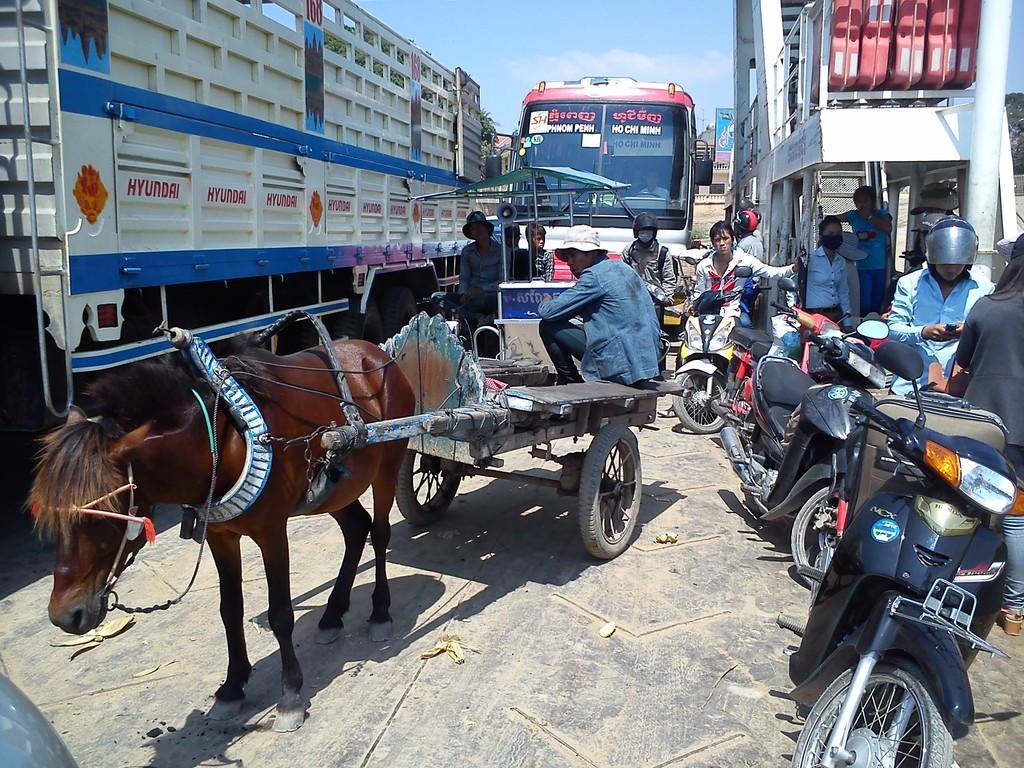Please provide a concise description of this image. This image consists of a horse cart. The horse is in brown color. There are many vehicles in this image. To the left, there is a truck. In the front, there is a bus. And there are many people. 